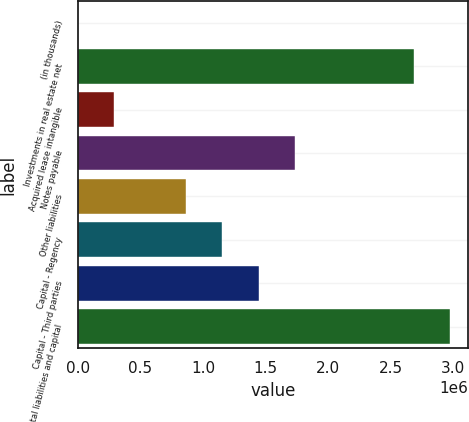<chart> <loc_0><loc_0><loc_500><loc_500><bar_chart><fcel>(in thousands)<fcel>Investments in real estate net<fcel>Acquired lease intangible<fcel>Notes payable<fcel>Other liabilities<fcel>Capital - Regency<fcel>Capital - Third parties<fcel>Total liabilities and capital<nl><fcel>2017<fcel>2.68258e+06<fcel>290387<fcel>1.73224e+06<fcel>867128<fcel>1.1555e+06<fcel>1.44387e+06<fcel>2.97095e+06<nl></chart> 